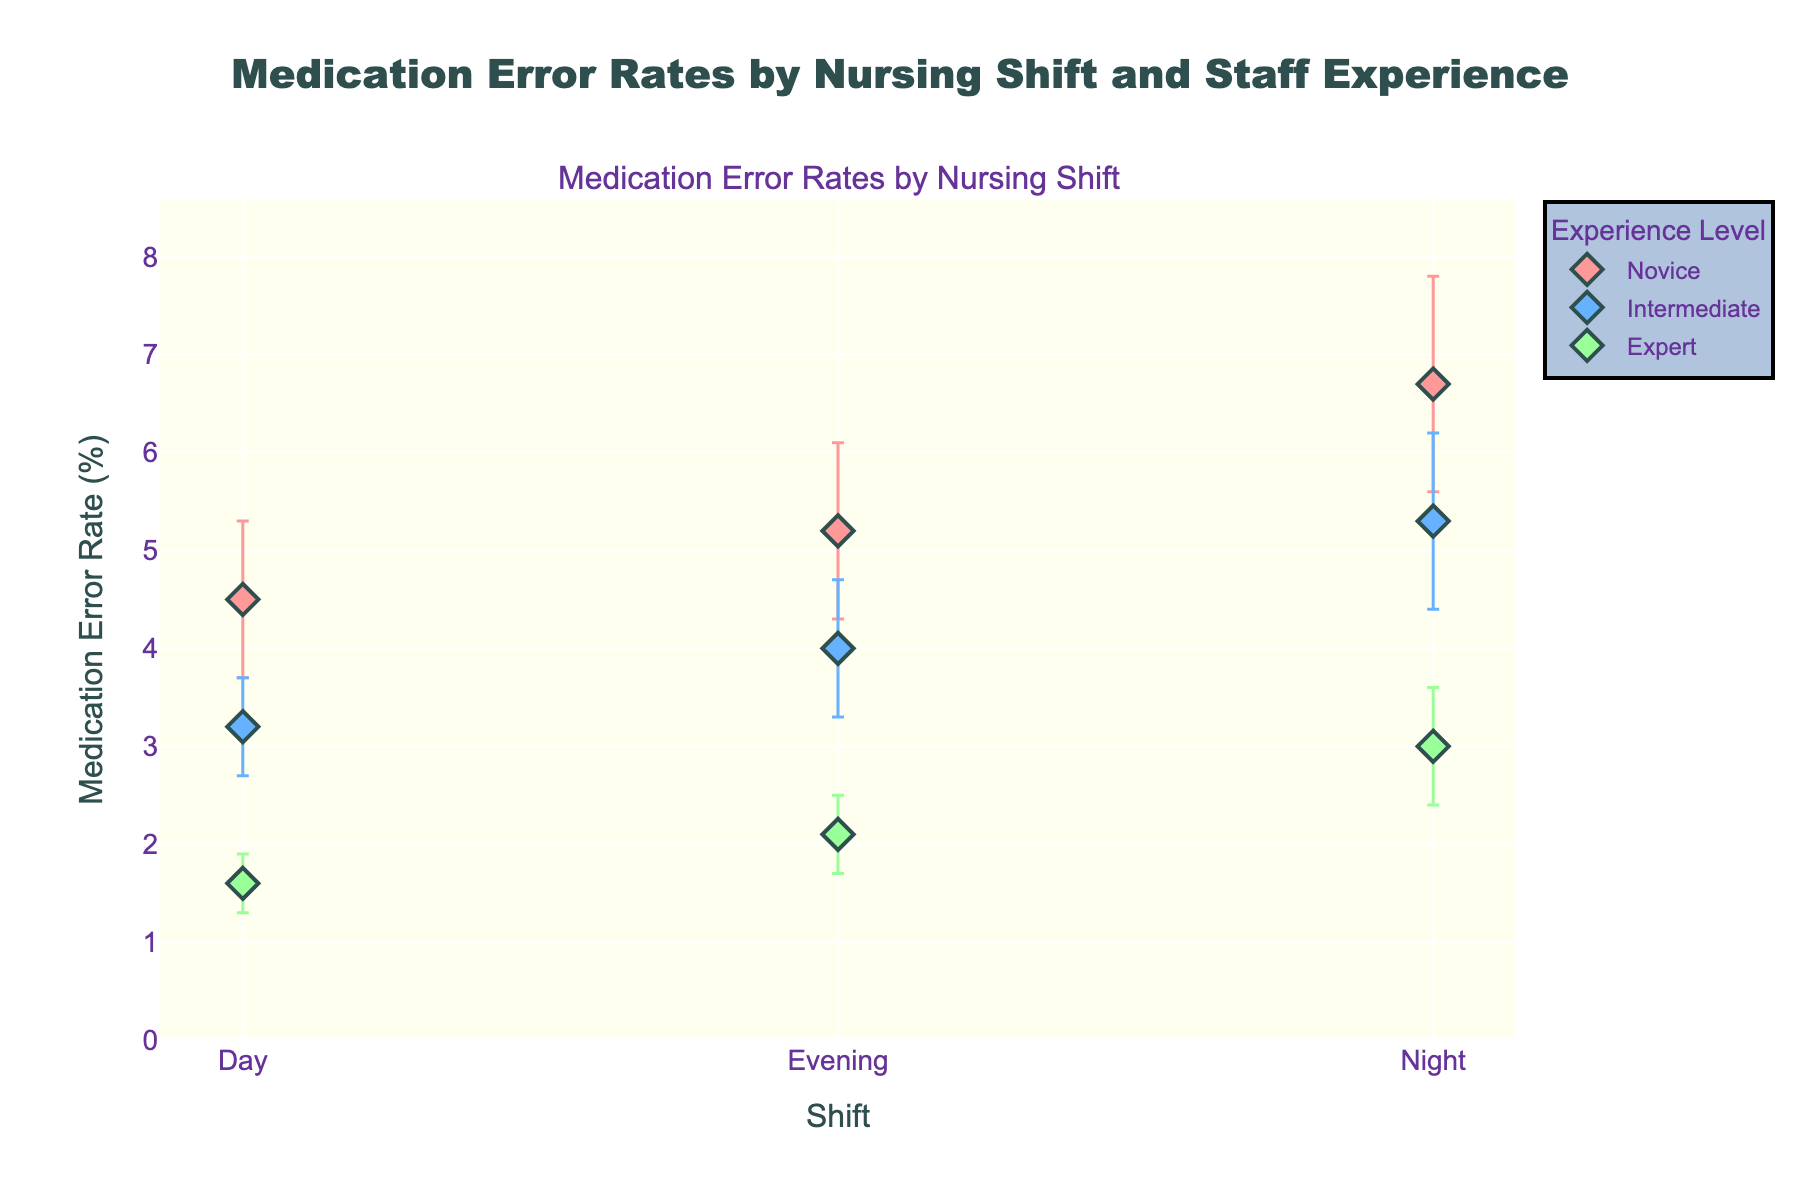What's the title of the plot? Look at the top of the plot where the main title is presented. This title often summarizes the information displayed.
Answer: "Medication Error Rates by Nursing Shift and Staff Experience" What is the medication error rate for expert staff on the evening shift? Identify the data point corresponding to the 'Evening' shift and 'Expert' experience level. Follow the y-axis value for this point.
Answer: 2.1 Which shift has the highest medication error rate for novice staff? Compare the medication error rates for novice staff across all shifts and identify the maximum value.
Answer: Night What is the average medication error rate for intermediate staff across all shifts? Calculate the mean of the medication error rates for intermediate staff across 'Day,' 'Evening,' and 'Night' shifts: (3.2 + 4.0 + 5.3) / 3.
Answer: 4.17 Is there a shift where the medication error rate for expert staff is higher than that for intermediate staff? Compare the medication error rates of expert and intermediate staff across all shifts. Ensure you check if any expert rate surpasses the intermediate rate.
Answer: No Which experience level has the least variability in medication error rates across shifts? Assess the standard deviations of medication error rates for each experience level and identify the smallest SD.
Answer: Expert What's the difference in medication error rates between novice and expert staff on the day shift? Subtract the error rate of expert staff from that of novice staff on the day shift: 4.5 - 1.6.
Answer: 2.9 Which shift shows the widest variability in medication error rates for novice staff? Compare the standard deviations of medication error rates for novice staff across all shifts and identify the largest SD.
Answer: Night Is the medication error rate trend for novice staff across shifts increasing or decreasing? Observe the order of medication error rates for novice staff from 'Day' to 'Evening' to 'Night'.
Answer: Increasing How does the medication error rate for intermediate staff on the night shift compare to that of novice staff on the evening shift? Compare the medication error rates directly for 'Intermediate' on 'Night' shift and 'Novice' on 'Evening' shift.
Answer: Intermediate on night shift is lower by 0.1 